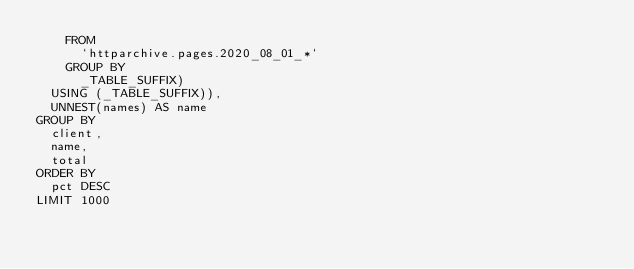Convert code to text. <code><loc_0><loc_0><loc_500><loc_500><_SQL_>    FROM
      `httparchive.pages.2020_08_01_*`
    GROUP BY
      _TABLE_SUFFIX)
  USING (_TABLE_SUFFIX)),
  UNNEST(names) AS name
GROUP BY
  client,
  name,
  total
ORDER BY
  pct DESC
LIMIT 1000
</code> 